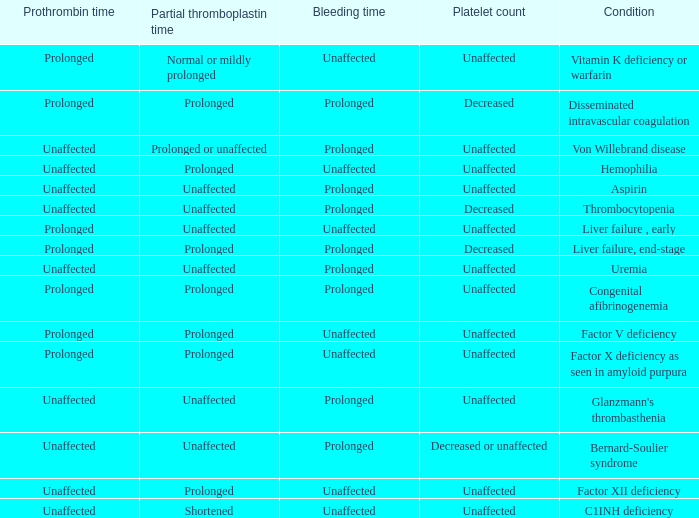Can you give me this table as a dict? {'header': ['Prothrombin time', 'Partial thromboplastin time', 'Bleeding time', 'Platelet count', 'Condition'], 'rows': [['Prolonged', 'Normal or mildly prolonged', 'Unaffected', 'Unaffected', 'Vitamin K deficiency or warfarin'], ['Prolonged', 'Prolonged', 'Prolonged', 'Decreased', 'Disseminated intravascular coagulation'], ['Unaffected', 'Prolonged or unaffected', 'Prolonged', 'Unaffected', 'Von Willebrand disease'], ['Unaffected', 'Prolonged', 'Unaffected', 'Unaffected', 'Hemophilia'], ['Unaffected', 'Unaffected', 'Prolonged', 'Unaffected', 'Aspirin'], ['Unaffected', 'Unaffected', 'Prolonged', 'Decreased', 'Thrombocytopenia'], ['Prolonged', 'Unaffected', 'Unaffected', 'Unaffected', 'Liver failure , early'], ['Prolonged', 'Prolonged', 'Prolonged', 'Decreased', 'Liver failure, end-stage'], ['Unaffected', 'Unaffected', 'Prolonged', 'Unaffected', 'Uremia'], ['Prolonged', 'Prolonged', 'Prolonged', 'Unaffected', 'Congenital afibrinogenemia'], ['Prolonged', 'Prolonged', 'Unaffected', 'Unaffected', 'Factor V deficiency'], ['Prolonged', 'Prolonged', 'Unaffected', 'Unaffected', 'Factor X deficiency as seen in amyloid purpura'], ['Unaffected', 'Unaffected', 'Prolonged', 'Unaffected', "Glanzmann's thrombasthenia"], ['Unaffected', 'Unaffected', 'Prolonged', 'Decreased or unaffected', 'Bernard-Soulier syndrome'], ['Unaffected', 'Prolonged', 'Unaffected', 'Unaffected', 'Factor XII deficiency'], ['Unaffected', 'Shortened', 'Unaffected', 'Unaffected', 'C1INH deficiency']]} Which partial thromboplastin time signifies early liver dysfunction condition? Unaffected. 